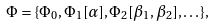Convert formula to latex. <formula><loc_0><loc_0><loc_500><loc_500>\Phi = \{ \Phi _ { 0 } , \Phi _ { 1 } [ \alpha ] , \Phi _ { 2 } [ \beta _ { 1 } , \beta _ { 2 } ] , \dots \} ,</formula> 